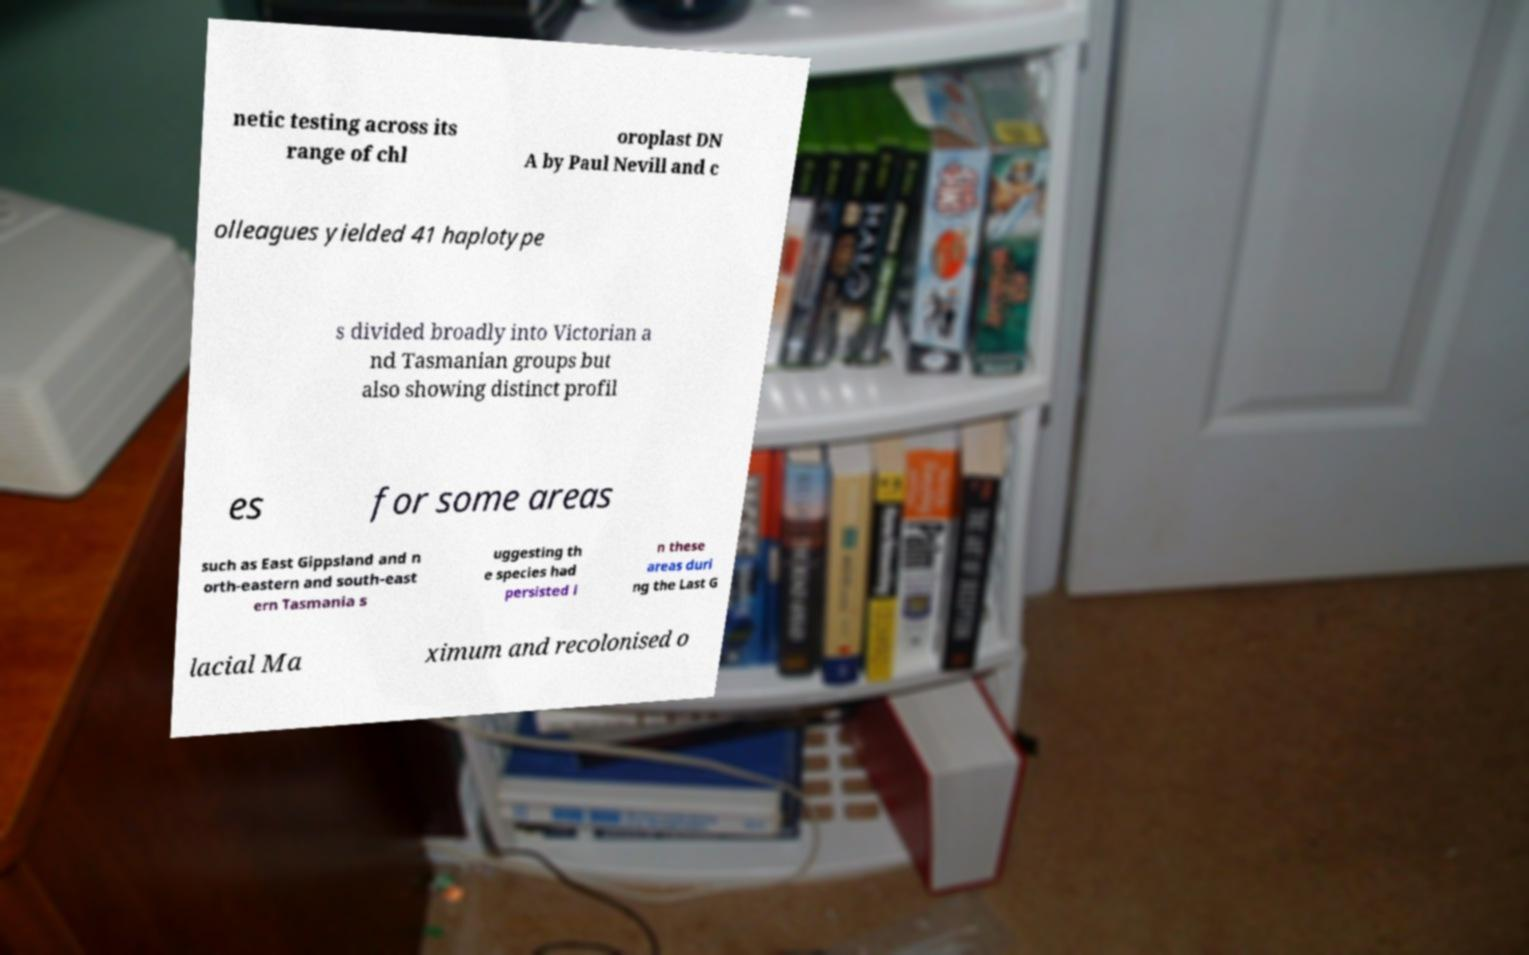Could you assist in decoding the text presented in this image and type it out clearly? netic testing across its range of chl oroplast DN A by Paul Nevill and c olleagues yielded 41 haplotype s divided broadly into Victorian a nd Tasmanian groups but also showing distinct profil es for some areas such as East Gippsland and n orth-eastern and south-east ern Tasmania s uggesting th e species had persisted i n these areas duri ng the Last G lacial Ma ximum and recolonised o 